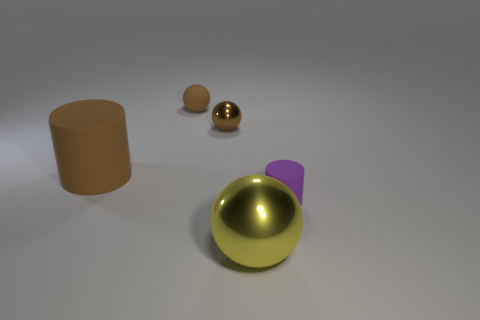Add 2 tiny blue blocks. How many objects exist? 7 Subtract all spheres. How many objects are left? 2 Add 1 tiny yellow rubber cubes. How many tiny yellow rubber cubes exist? 1 Subtract 1 brown cylinders. How many objects are left? 4 Subtract all big green cylinders. Subtract all tiny brown metal spheres. How many objects are left? 4 Add 1 tiny objects. How many tiny objects are left? 4 